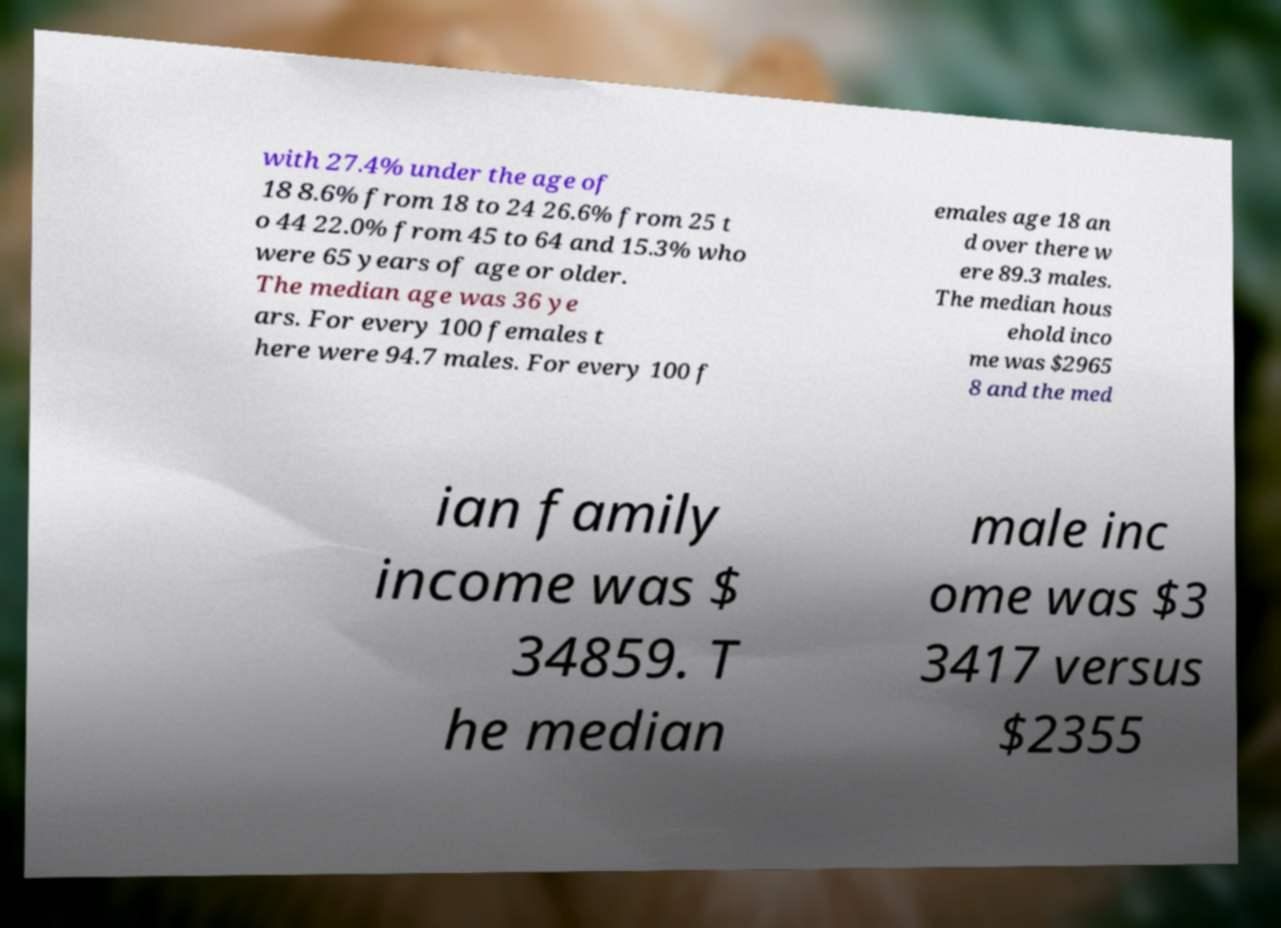Please identify and transcribe the text found in this image. with 27.4% under the age of 18 8.6% from 18 to 24 26.6% from 25 t o 44 22.0% from 45 to 64 and 15.3% who were 65 years of age or older. The median age was 36 ye ars. For every 100 females t here were 94.7 males. For every 100 f emales age 18 an d over there w ere 89.3 males. The median hous ehold inco me was $2965 8 and the med ian family income was $ 34859. T he median male inc ome was $3 3417 versus $2355 